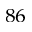Convert formula to latex. <formula><loc_0><loc_0><loc_500><loc_500>^ { 8 6 }</formula> 